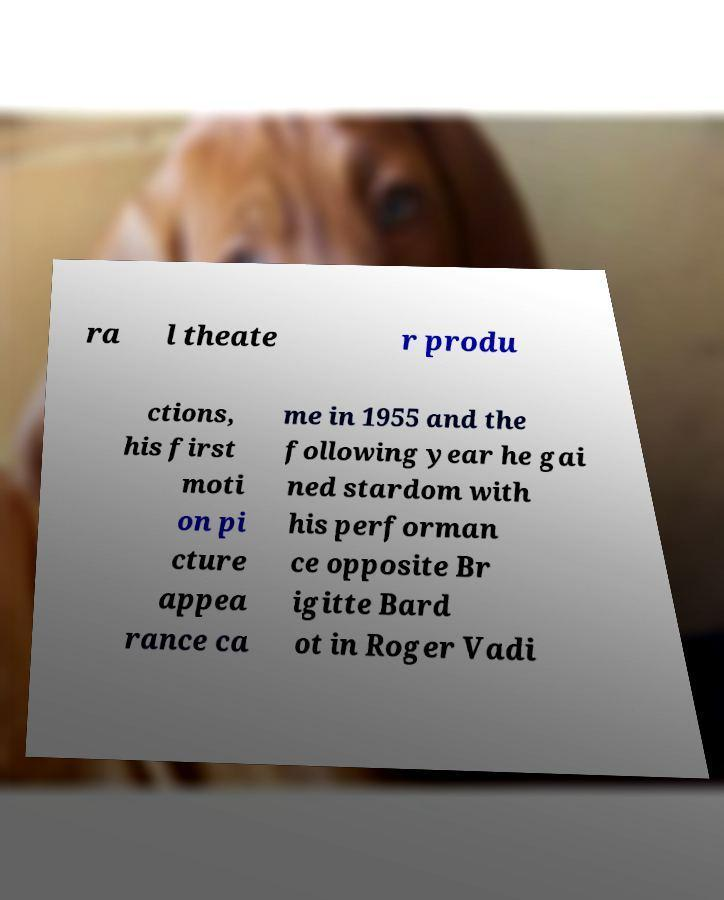I need the written content from this picture converted into text. Can you do that? ra l theate r produ ctions, his first moti on pi cture appea rance ca me in 1955 and the following year he gai ned stardom with his performan ce opposite Br igitte Bard ot in Roger Vadi 